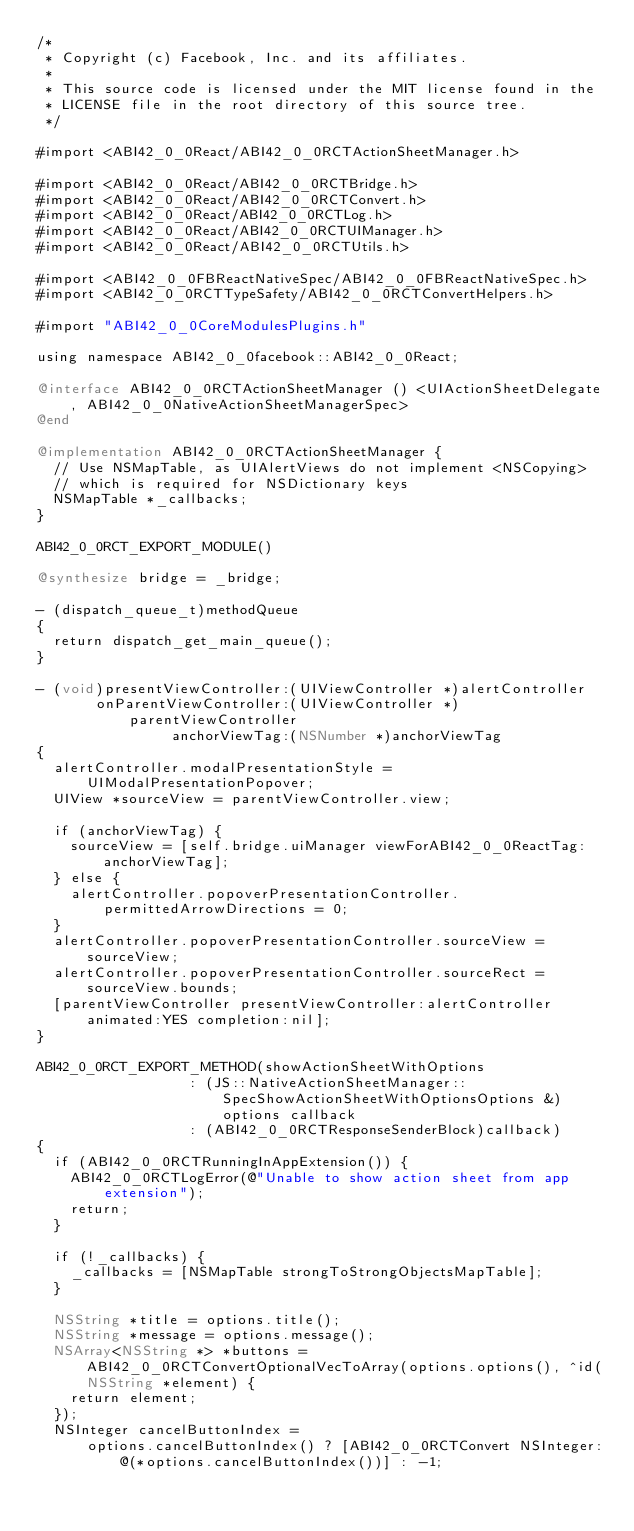<code> <loc_0><loc_0><loc_500><loc_500><_ObjectiveC_>/*
 * Copyright (c) Facebook, Inc. and its affiliates.
 *
 * This source code is licensed under the MIT license found in the
 * LICENSE file in the root directory of this source tree.
 */

#import <ABI42_0_0React/ABI42_0_0RCTActionSheetManager.h>

#import <ABI42_0_0React/ABI42_0_0RCTBridge.h>
#import <ABI42_0_0React/ABI42_0_0RCTConvert.h>
#import <ABI42_0_0React/ABI42_0_0RCTLog.h>
#import <ABI42_0_0React/ABI42_0_0RCTUIManager.h>
#import <ABI42_0_0React/ABI42_0_0RCTUtils.h>

#import <ABI42_0_0FBReactNativeSpec/ABI42_0_0FBReactNativeSpec.h>
#import <ABI42_0_0RCTTypeSafety/ABI42_0_0RCTConvertHelpers.h>

#import "ABI42_0_0CoreModulesPlugins.h"

using namespace ABI42_0_0facebook::ABI42_0_0React;

@interface ABI42_0_0RCTActionSheetManager () <UIActionSheetDelegate, ABI42_0_0NativeActionSheetManagerSpec>
@end

@implementation ABI42_0_0RCTActionSheetManager {
  // Use NSMapTable, as UIAlertViews do not implement <NSCopying>
  // which is required for NSDictionary keys
  NSMapTable *_callbacks;
}

ABI42_0_0RCT_EXPORT_MODULE()

@synthesize bridge = _bridge;

- (dispatch_queue_t)methodQueue
{
  return dispatch_get_main_queue();
}

- (void)presentViewController:(UIViewController *)alertController
       onParentViewController:(UIViewController *)parentViewController
                anchorViewTag:(NSNumber *)anchorViewTag
{
  alertController.modalPresentationStyle = UIModalPresentationPopover;
  UIView *sourceView = parentViewController.view;

  if (anchorViewTag) {
    sourceView = [self.bridge.uiManager viewForABI42_0_0ReactTag:anchorViewTag];
  } else {
    alertController.popoverPresentationController.permittedArrowDirections = 0;
  }
  alertController.popoverPresentationController.sourceView = sourceView;
  alertController.popoverPresentationController.sourceRect = sourceView.bounds;
  [parentViewController presentViewController:alertController animated:YES completion:nil];
}

ABI42_0_0RCT_EXPORT_METHOD(showActionSheetWithOptions
                  : (JS::NativeActionSheetManager::SpecShowActionSheetWithOptionsOptions &)options callback
                  : (ABI42_0_0RCTResponseSenderBlock)callback)
{
  if (ABI42_0_0RCTRunningInAppExtension()) {
    ABI42_0_0RCTLogError(@"Unable to show action sheet from app extension");
    return;
  }

  if (!_callbacks) {
    _callbacks = [NSMapTable strongToStrongObjectsMapTable];
  }

  NSString *title = options.title();
  NSString *message = options.message();
  NSArray<NSString *> *buttons = ABI42_0_0RCTConvertOptionalVecToArray(options.options(), ^id(NSString *element) {
    return element;
  });
  NSInteger cancelButtonIndex =
      options.cancelButtonIndex() ? [ABI42_0_0RCTConvert NSInteger:@(*options.cancelButtonIndex())] : -1;</code> 